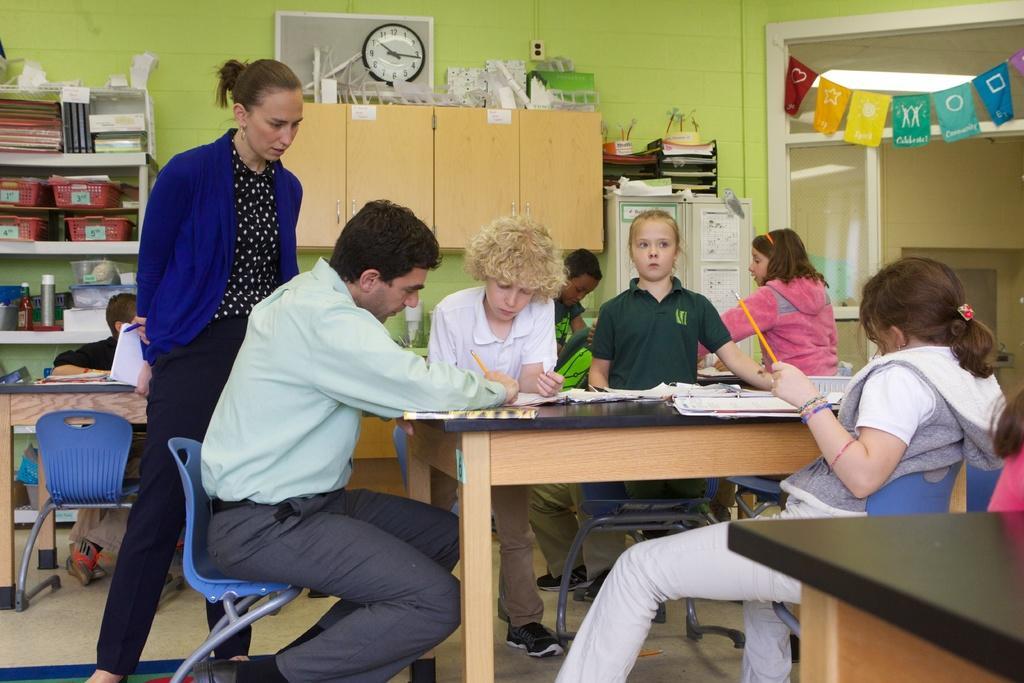Could you give a brief overview of what you see in this image? The image consists of kids and man sitting around a table on a chair looking at books. this seems to be of a classroom on the background there is cupboard shelves with many things on it and there is clock at center of the room and at the right side there is an entrance door. 